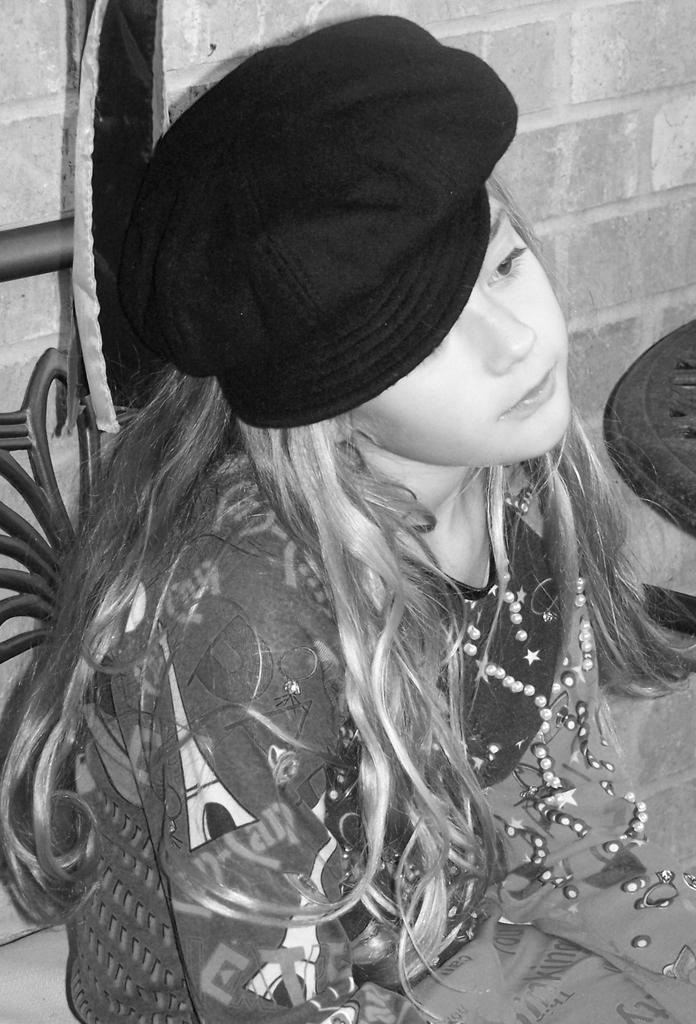Who is the main subject in the image? There is a girl in the image. What is the girl wearing on her head? The girl is wearing a hat. What is the girl's position in the image? The girl is seated on a chair. What can be seen in the background of the image? There is a brick wall in the background of the image. What decision did the girl make in the image? There is no information about the girl making a decision in the image. 